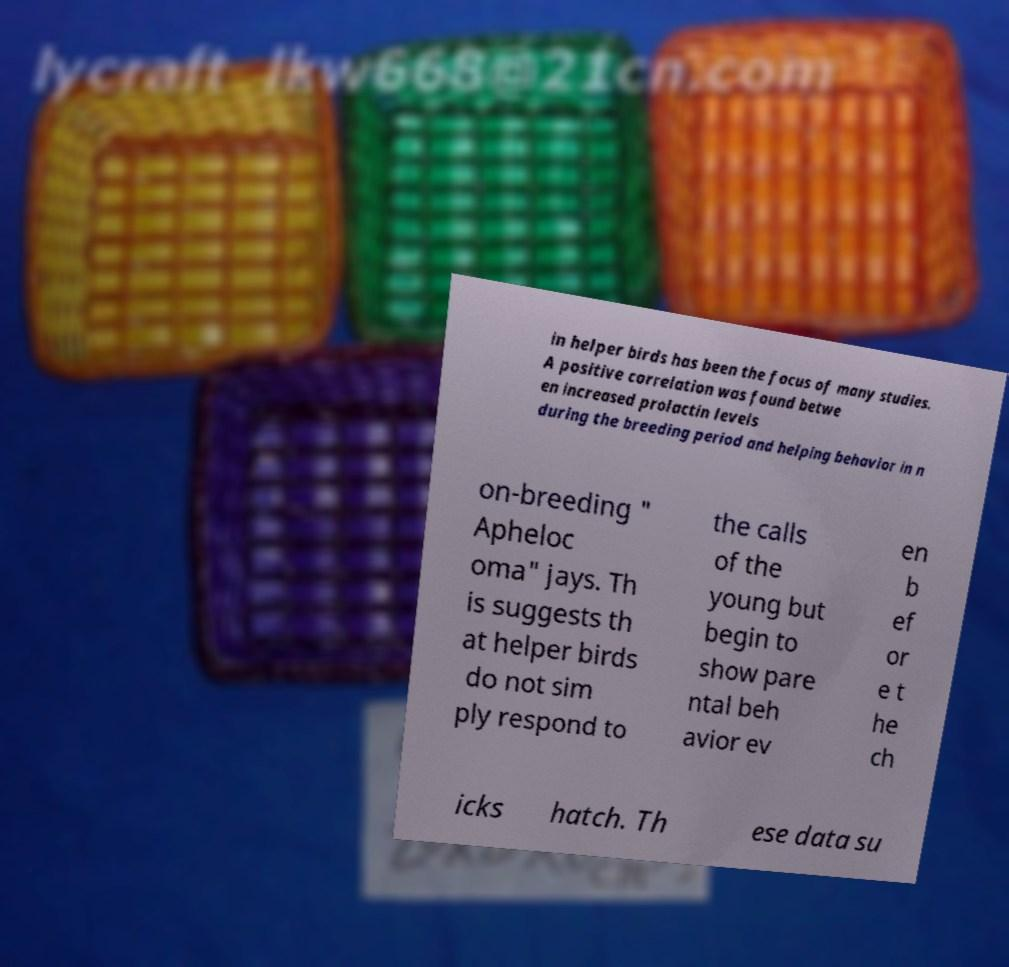Could you assist in decoding the text presented in this image and type it out clearly? in helper birds has been the focus of many studies. A positive correlation was found betwe en increased prolactin levels during the breeding period and helping behavior in n on-breeding " Apheloc oma" jays. Th is suggests th at helper birds do not sim ply respond to the calls of the young but begin to show pare ntal beh avior ev en b ef or e t he ch icks hatch. Th ese data su 